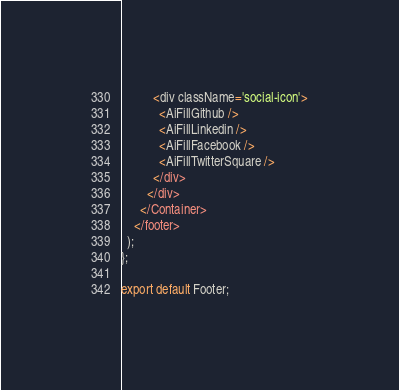<code> <loc_0><loc_0><loc_500><loc_500><_JavaScript_>          <div className='social-icon'>
            <AiFillGithub />
            <AiFillLinkedin />
            <AiFillFacebook />
            <AiFillTwitterSquare />
          </div>
        </div>
      </Container>
    </footer>
  );
};

export default Footer;
</code> 